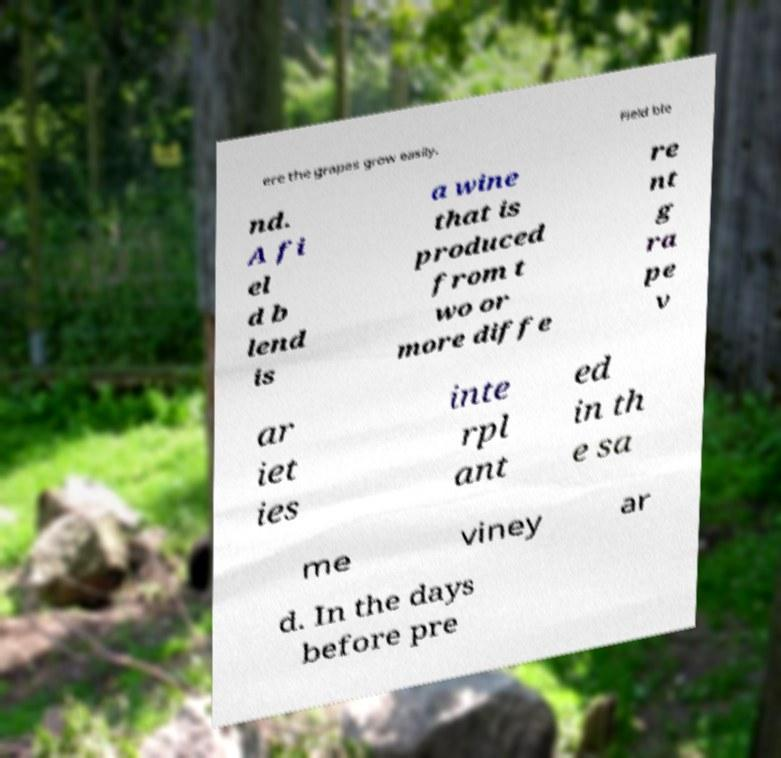Please read and relay the text visible in this image. What does it say? ere the grapes grow easily. Field ble nd. A fi el d b lend is a wine that is produced from t wo or more diffe re nt g ra pe v ar iet ies inte rpl ant ed in th e sa me viney ar d. In the days before pre 